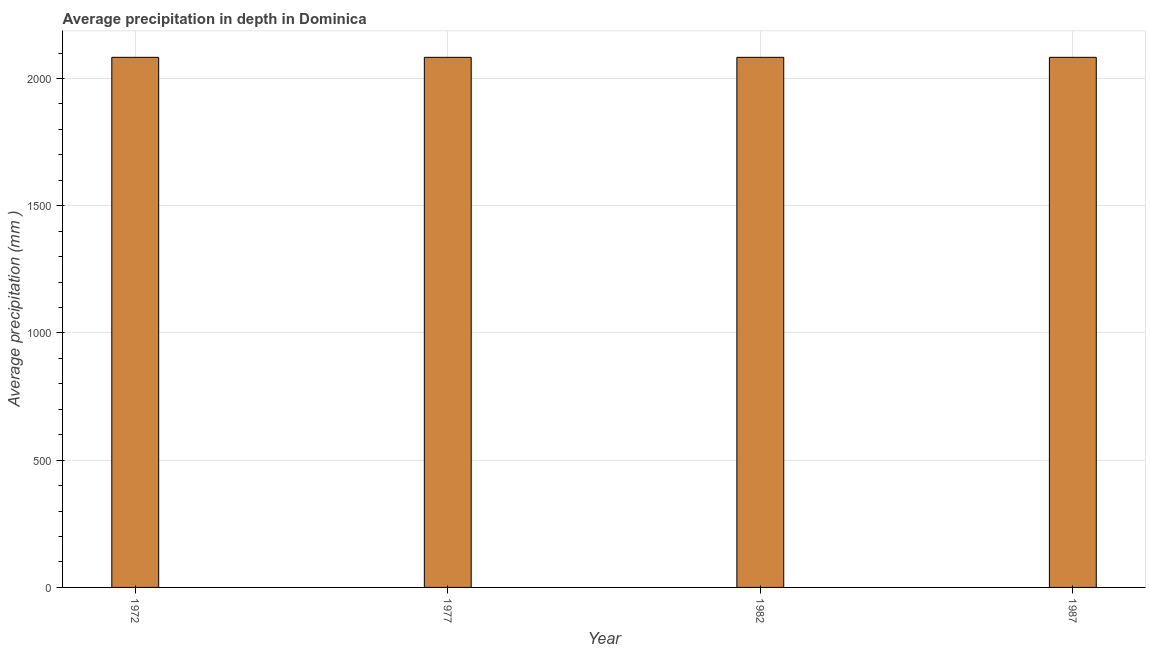Does the graph contain any zero values?
Provide a succinct answer. No. What is the title of the graph?
Provide a succinct answer. Average precipitation in depth in Dominica. What is the label or title of the X-axis?
Your answer should be compact. Year. What is the label or title of the Y-axis?
Your answer should be compact. Average precipitation (mm ). What is the average precipitation in depth in 1977?
Your answer should be very brief. 2083. Across all years, what is the maximum average precipitation in depth?
Offer a terse response. 2083. Across all years, what is the minimum average precipitation in depth?
Offer a terse response. 2083. What is the sum of the average precipitation in depth?
Offer a very short reply. 8332. What is the difference between the average precipitation in depth in 1972 and 1982?
Offer a very short reply. 0. What is the average average precipitation in depth per year?
Offer a terse response. 2083. What is the median average precipitation in depth?
Keep it short and to the point. 2083. Do a majority of the years between 1977 and 1982 (inclusive) have average precipitation in depth greater than 1400 mm?
Offer a very short reply. Yes. What is the ratio of the average precipitation in depth in 1977 to that in 1982?
Make the answer very short. 1. Is the average precipitation in depth in 1972 less than that in 1977?
Offer a terse response. No. Is the difference between the average precipitation in depth in 1972 and 1987 greater than the difference between any two years?
Your answer should be very brief. Yes. Is the sum of the average precipitation in depth in 1972 and 1982 greater than the maximum average precipitation in depth across all years?
Give a very brief answer. Yes. What is the difference between the highest and the lowest average precipitation in depth?
Offer a terse response. 0. In how many years, is the average precipitation in depth greater than the average average precipitation in depth taken over all years?
Keep it short and to the point. 0. Are all the bars in the graph horizontal?
Make the answer very short. No. What is the Average precipitation (mm ) of 1972?
Your response must be concise. 2083. What is the Average precipitation (mm ) of 1977?
Provide a short and direct response. 2083. What is the Average precipitation (mm ) in 1982?
Provide a short and direct response. 2083. What is the Average precipitation (mm ) of 1987?
Provide a succinct answer. 2083. What is the difference between the Average precipitation (mm ) in 1972 and 1977?
Your answer should be compact. 0. What is the difference between the Average precipitation (mm ) in 1972 and 1987?
Your answer should be very brief. 0. What is the difference between the Average precipitation (mm ) in 1977 and 1982?
Your answer should be compact. 0. What is the difference between the Average precipitation (mm ) in 1977 and 1987?
Provide a short and direct response. 0. What is the difference between the Average precipitation (mm ) in 1982 and 1987?
Your response must be concise. 0. What is the ratio of the Average precipitation (mm ) in 1972 to that in 1977?
Your response must be concise. 1. What is the ratio of the Average precipitation (mm ) in 1972 to that in 1982?
Provide a short and direct response. 1. What is the ratio of the Average precipitation (mm ) in 1972 to that in 1987?
Your answer should be compact. 1. What is the ratio of the Average precipitation (mm ) in 1977 to that in 1987?
Keep it short and to the point. 1. What is the ratio of the Average precipitation (mm ) in 1982 to that in 1987?
Offer a very short reply. 1. 